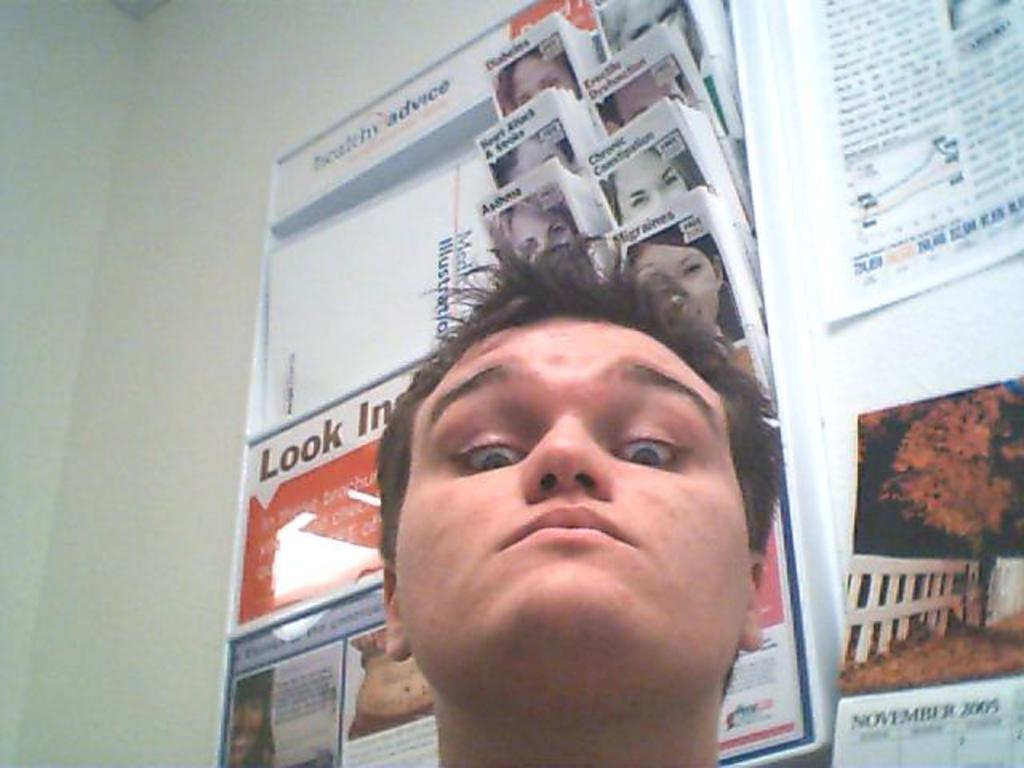Can you describe this image briefly? In this picture I can see a man and couple of posters on the wall with some text and I can see few papers in the paper stand. 